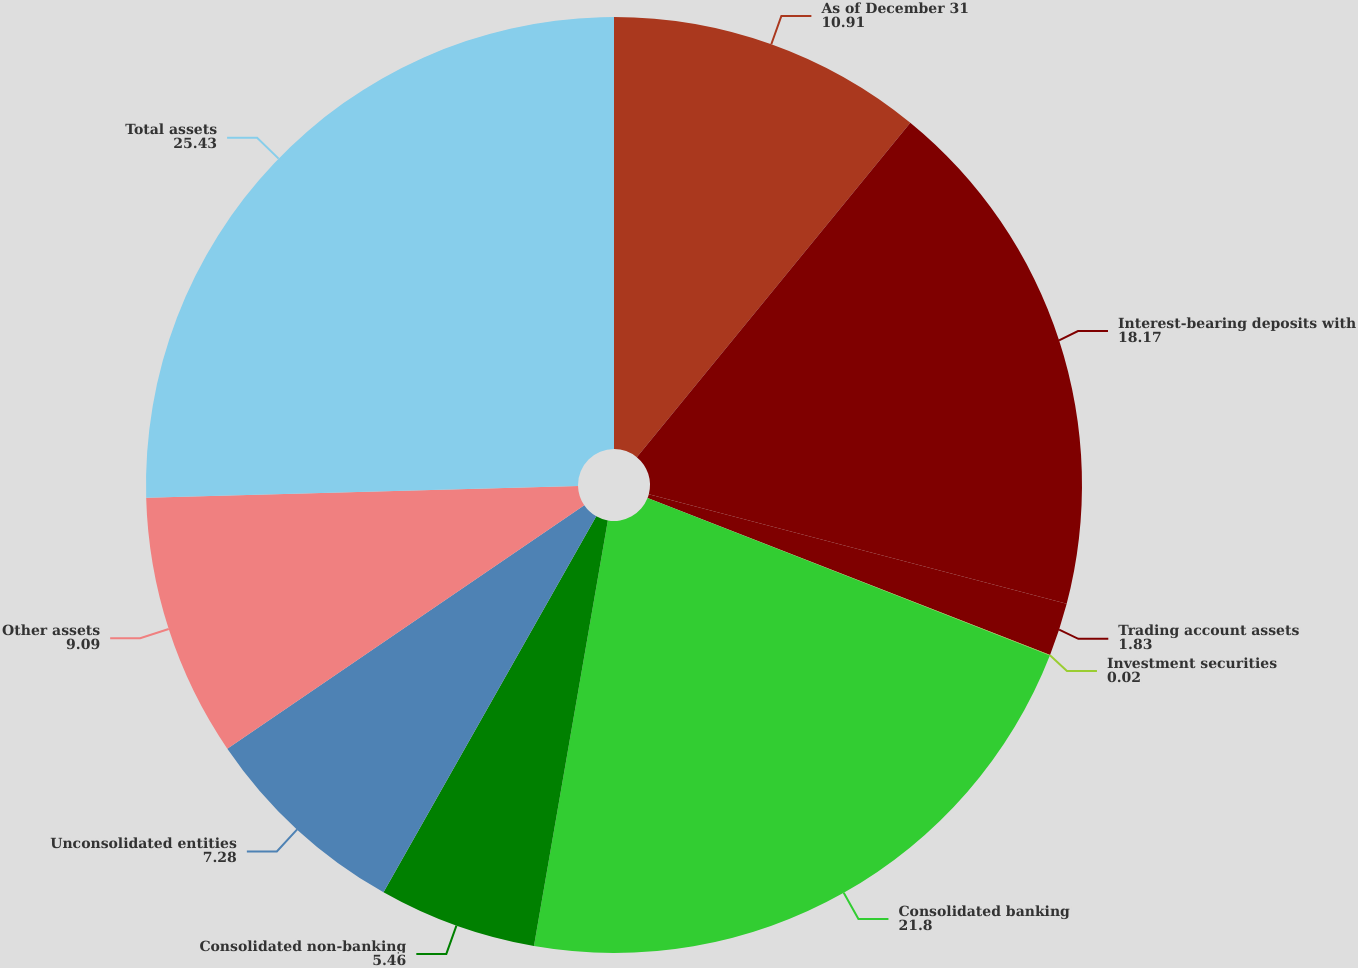Convert chart. <chart><loc_0><loc_0><loc_500><loc_500><pie_chart><fcel>As of December 31<fcel>Interest-bearing deposits with<fcel>Trading account assets<fcel>Investment securities<fcel>Consolidated banking<fcel>Consolidated non-banking<fcel>Unconsolidated entities<fcel>Other assets<fcel>Total assets<nl><fcel>10.91%<fcel>18.17%<fcel>1.83%<fcel>0.02%<fcel>21.8%<fcel>5.46%<fcel>7.28%<fcel>9.09%<fcel>25.43%<nl></chart> 